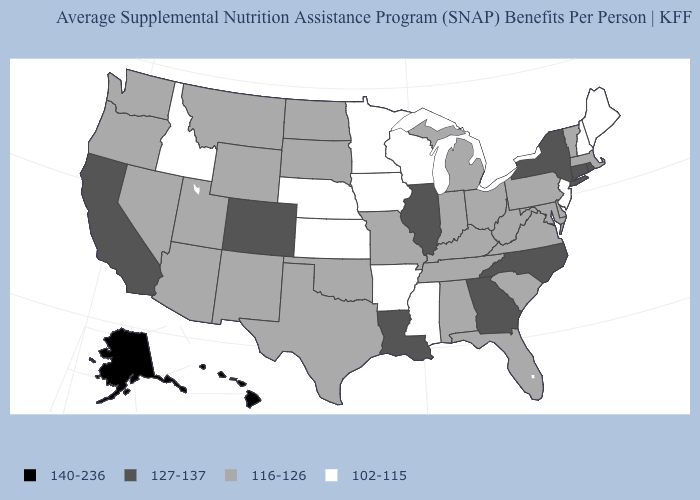Name the states that have a value in the range 102-115?
Give a very brief answer. Arkansas, Idaho, Iowa, Kansas, Maine, Minnesota, Mississippi, Nebraska, New Hampshire, New Jersey, Wisconsin. Does Alaska have the highest value in the USA?
Answer briefly. Yes. How many symbols are there in the legend?
Quick response, please. 4. Among the states that border Virginia , which have the highest value?
Give a very brief answer. North Carolina. Among the states that border Massachusetts , does Vermont have the highest value?
Be succinct. No. Name the states that have a value in the range 102-115?
Be succinct. Arkansas, Idaho, Iowa, Kansas, Maine, Minnesota, Mississippi, Nebraska, New Hampshire, New Jersey, Wisconsin. Does Georgia have the same value as Nebraska?
Be succinct. No. Is the legend a continuous bar?
Answer briefly. No. Does Arkansas have the lowest value in the USA?
Be succinct. Yes. Name the states that have a value in the range 127-137?
Quick response, please. California, Colorado, Connecticut, Georgia, Illinois, Louisiana, New York, North Carolina, Rhode Island. What is the value of Nevada?
Write a very short answer. 116-126. What is the value of Maryland?
Be succinct. 116-126. Does Illinois have the highest value in the MidWest?
Answer briefly. Yes. Does Utah have the lowest value in the West?
Be succinct. No. Among the states that border Vermont , which have the lowest value?
Short answer required. New Hampshire. 